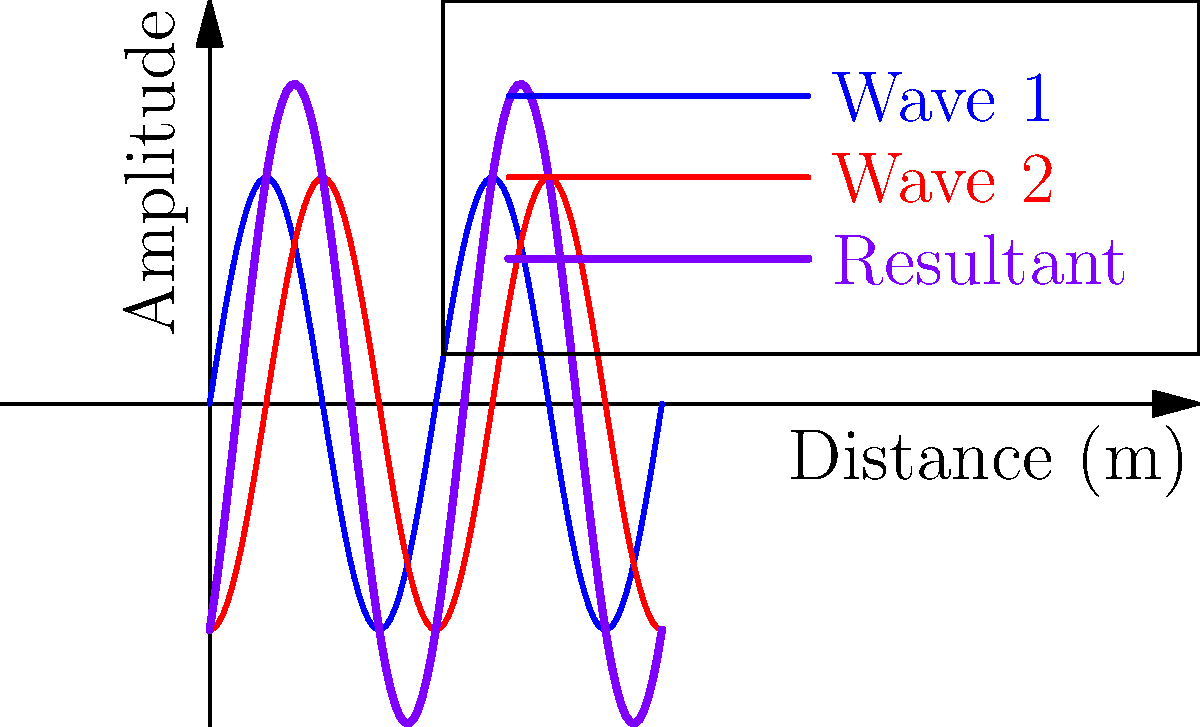In a concert hall, two speakers are producing sound waves with the same frequency and amplitude, but one speaker is positioned a quarter-wavelength behind the other. As a pianist interested in acoustics, you need to determine the phase difference between these two waves and calculate the amplitude of the resultant wave at a point where both waves interfere constructively. Given that each wave has an amplitude of 2 units, what is the maximum amplitude of the resultant wave? Let's approach this step-by-step:

1) First, we need to determine the phase difference between the two waves. Given that one speaker is positioned a quarter-wavelength behind the other, we can calculate the phase difference:

   Phase difference = $\frac{1}{4} \times 2\pi = \frac{\pi}{2}$ radians

2) For constructive interference to occur, the waves must be in phase. This happens when the path difference is equal to whole number multiples of the wavelength. In this case, it occurs at points where the second wave has "caught up" by 3/4 of a wavelength.

3) At these points of constructive interference, the amplitudes of the two waves add together. We can calculate this using the principle of superposition.

4) The amplitude of each wave is 2 units. To find the resultant amplitude, we add these vectorially:

   Resultant Amplitude = $\sqrt{A_1^2 + A_2^2 + 2A_1A_2\cos(\theta)}$

   Where $A_1$ and $A_2$ are the amplitudes of the individual waves, and $\theta$ is the phase difference.

5) Substituting our values:

   Resultant Amplitude = $\sqrt{2^2 + 2^2 + 2(2)(2)\cos(\frac{\pi}{2})}$

6) Simplify:
   
   Resultant Amplitude = $\sqrt{4 + 4 + 8\cos(\frac{\pi}{2})}$
                       = $\sqrt{8 + 8(0)}$ (since $\cos(\frac{\pi}{2}) = 0$)
                       = $\sqrt{8}$
                       = $2\sqrt{2}$ units

Therefore, the maximum amplitude of the resultant wave is $2\sqrt{2}$ units.
Answer: $2\sqrt{2}$ units 